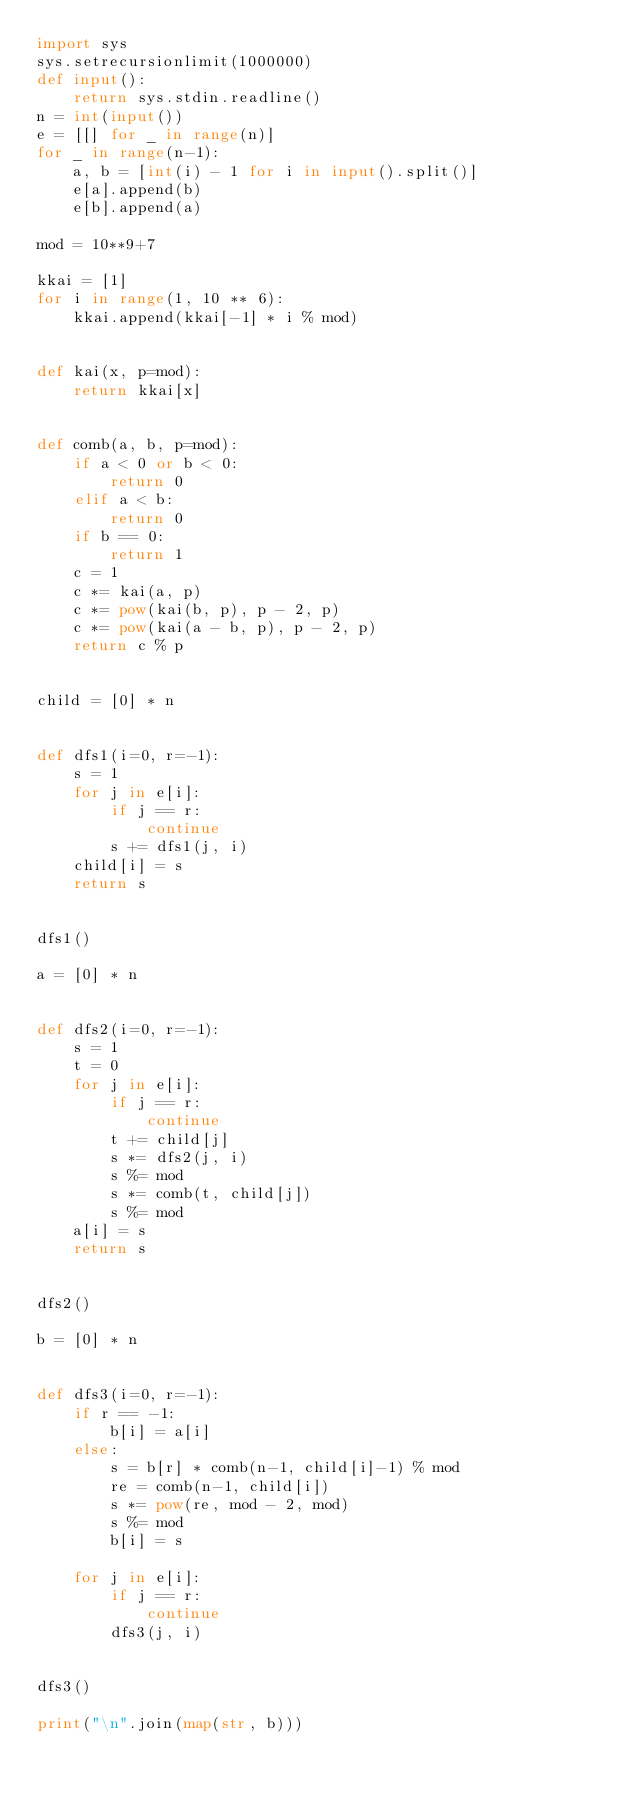<code> <loc_0><loc_0><loc_500><loc_500><_Python_>import sys
sys.setrecursionlimit(1000000)
def input():
    return sys.stdin.readline()
n = int(input())
e = [[] for _ in range(n)]
for _ in range(n-1):
    a, b = [int(i) - 1 for i in input().split()]
    e[a].append(b)
    e[b].append(a)

mod = 10**9+7

kkai = [1]
for i in range(1, 10 ** 6):
    kkai.append(kkai[-1] * i % mod)


def kai(x, p=mod):
    return kkai[x]


def comb(a, b, p=mod):
    if a < 0 or b < 0:
        return 0
    elif a < b:
        return 0
    if b == 0:
        return 1
    c = 1
    c *= kai(a, p)
    c *= pow(kai(b, p), p - 2, p)
    c *= pow(kai(a - b, p), p - 2, p)
    return c % p


child = [0] * n


def dfs1(i=0, r=-1):
    s = 1
    for j in e[i]:
        if j == r:
            continue
        s += dfs1(j, i)
    child[i] = s
    return s


dfs1()

a = [0] * n


def dfs2(i=0, r=-1):
    s = 1
    t = 0
    for j in e[i]:
        if j == r:
            continue
        t += child[j]
        s *= dfs2(j, i)
        s %= mod
        s *= comb(t, child[j])
        s %= mod
    a[i] = s
    return s


dfs2()

b = [0] * n


def dfs3(i=0, r=-1):
    if r == -1:
        b[i] = a[i]
    else:
        s = b[r] * comb(n-1, child[i]-1) % mod
        re = comb(n-1, child[i])
        s *= pow(re, mod - 2, mod)
        s %= mod
        b[i] = s

    for j in e[i]:
        if j == r:
            continue
        dfs3(j, i)


dfs3()

print("\n".join(map(str, b)))
</code> 